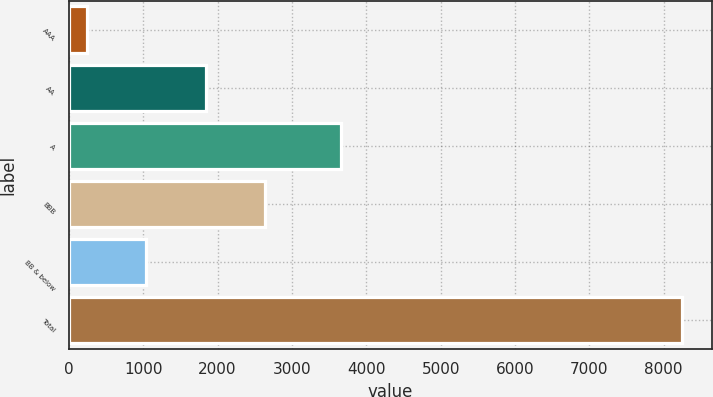Convert chart. <chart><loc_0><loc_0><loc_500><loc_500><bar_chart><fcel>AAA<fcel>AA<fcel>A<fcel>BBB<fcel>BB & below<fcel>Total<nl><fcel>240<fcel>1840.4<fcel>3664<fcel>2640.6<fcel>1040.2<fcel>8242<nl></chart> 